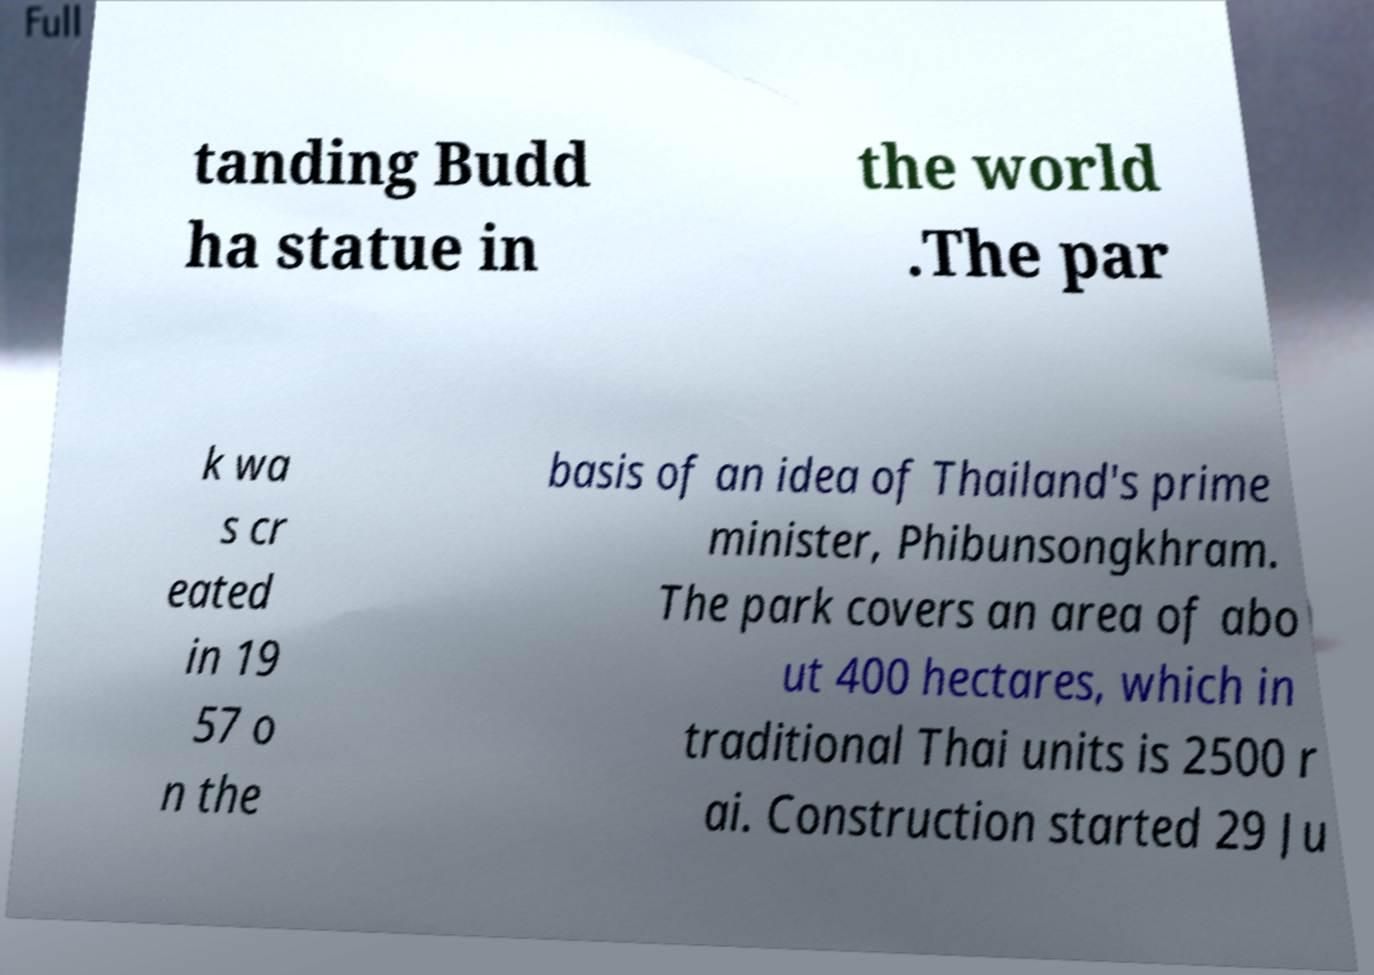What messages or text are displayed in this image? I need them in a readable, typed format. tanding Budd ha statue in the world .The par k wa s cr eated in 19 57 o n the basis of an idea of Thailand's prime minister, Phibunsongkhram. The park covers an area of abo ut 400 hectares, which in traditional Thai units is 2500 r ai. Construction started 29 Ju 